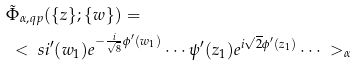Convert formula to latex. <formula><loc_0><loc_0><loc_500><loc_500>& \tilde { \Phi } _ { \alpha , q p } ( \{ z \} ; \{ w \} ) = \\ & \ < \ s i ^ { \prime } ( w _ { 1 } ) e ^ { - \frac { i } { \sqrt { 8 } } \phi ^ { \prime } ( w _ { 1 } ) } \cdots \psi ^ { \prime } ( z _ { 1 } ) e ^ { i \sqrt { 2 } \phi ^ { \prime } ( z _ { 1 } ) } \cdots \ > _ { \alpha }</formula> 